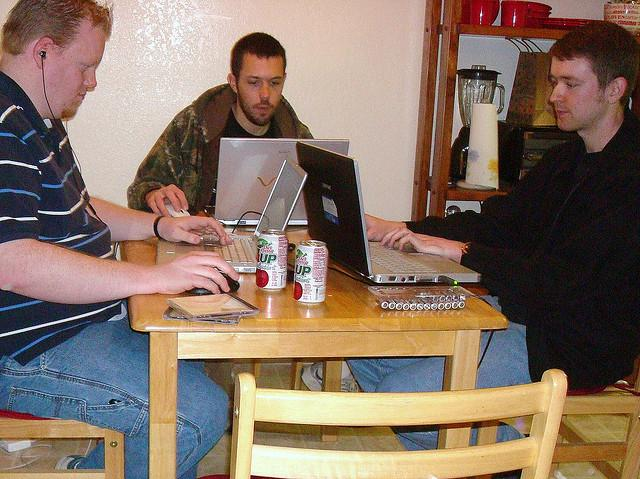Why are they all there together? working 